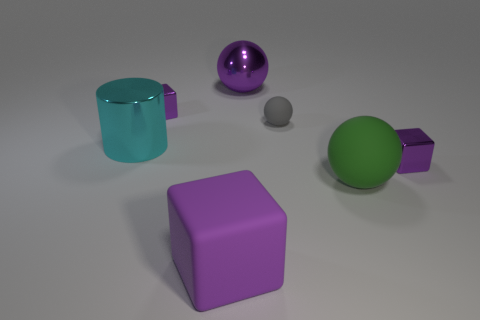The metallic sphere that is the same color as the matte cube is what size?
Your answer should be very brief. Large. Is the shape of the small rubber thing the same as the green thing?
Your answer should be very brief. Yes. What is the size of the purple matte object?
Provide a short and direct response. Large. Is the size of the rubber cube the same as the metallic cube in front of the tiny matte object?
Provide a succinct answer. No. Is the color of the matte cube the same as the metallic cube right of the purple matte cube?
Make the answer very short. Yes. What number of objects are tiny purple objects that are to the right of the purple sphere or large shiny things that are left of the large metal sphere?
Ensure brevity in your answer.  2. Is the number of tiny purple cubes that are right of the large cyan thing greater than the number of cubes that are left of the gray sphere?
Your response must be concise. No. What is the tiny purple cube on the left side of the large metal ball that is behind the small purple metal object that is on the right side of the tiny gray matte sphere made of?
Your response must be concise. Metal. There is a large purple object in front of the cyan metallic cylinder; is it the same shape as the purple object to the right of the big purple metal thing?
Provide a short and direct response. Yes. Is there a cyan rubber cylinder that has the same size as the purple sphere?
Your answer should be compact. No. 